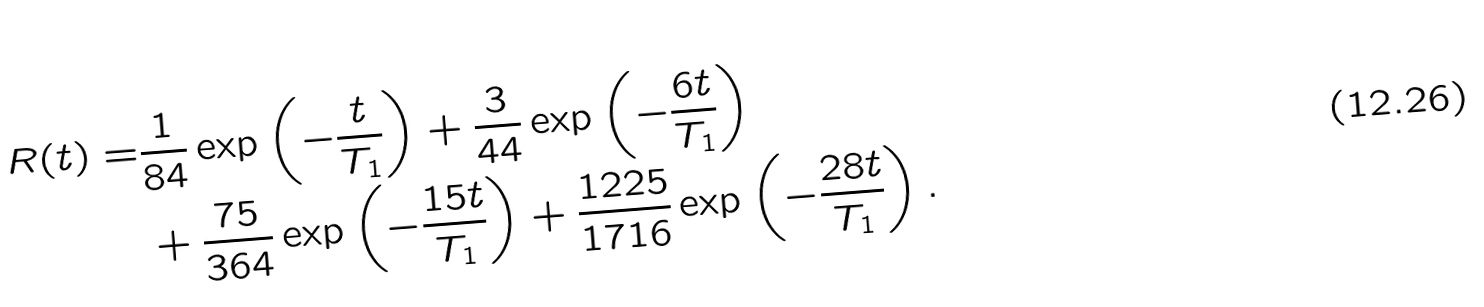Convert formula to latex. <formula><loc_0><loc_0><loc_500><loc_500>R ( t ) = & \frac { 1 } { 8 4 } \exp \left ( - \frac { t } { T _ { 1 } } \right ) + \frac { 3 } { 4 4 } \exp \left ( - \frac { 6 t } { T _ { 1 } } \right ) \\ & + \frac { 7 5 } { 3 6 4 } \exp \left ( - \frac { 1 5 t } { T _ { 1 } } \right ) + \frac { 1 2 2 5 } { 1 7 1 6 } \exp \left ( - \frac { 2 8 t } { T _ { 1 } } \right ) .</formula> 